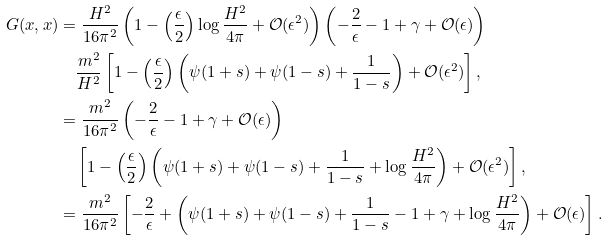Convert formula to latex. <formula><loc_0><loc_0><loc_500><loc_500>G ( x , x ) & = \frac { H ^ { 2 } } { 1 6 \pi ^ { 2 } } \left ( 1 - \left ( \frac { \epsilon } { 2 } \right ) \log \frac { H ^ { 2 } } { 4 \pi } + \mathcal { O } ( \epsilon ^ { 2 } ) \right ) \left ( - \frac { 2 } { \epsilon } - 1 + \gamma + \mathcal { O } ( \epsilon ) \right ) \\ & \quad \frac { m ^ { 2 } } { H ^ { 2 } } \left [ 1 - \left ( \frac { \epsilon } { 2 } \right ) \left ( \psi ( 1 + s ) + \psi ( 1 - s ) + \frac { 1 } { 1 - s } \right ) + \mathcal { O } ( \epsilon ^ { 2 } ) \right ] , \\ & = \frac { m ^ { 2 } } { 1 6 \pi ^ { 2 } } \left ( - \frac { 2 } { \epsilon } - 1 + \gamma + \mathcal { O } ( \epsilon ) \right ) \\ & \quad \left [ 1 - \left ( \frac { \epsilon } { 2 } \right ) \left ( \psi ( 1 + s ) + \psi ( 1 - s ) + \frac { 1 } { 1 - s } + \log \frac { H ^ { 2 } } { 4 \pi } \right ) + \mathcal { O } ( \epsilon ^ { 2 } ) \right ] , \\ & = \frac { m ^ { 2 } } { 1 6 \pi ^ { 2 } } \left [ - \frac { 2 } { \epsilon } + \left ( \psi ( 1 + s ) + \psi ( 1 - s ) + \frac { 1 } { 1 - s } - 1 + \gamma + \log \frac { H ^ { 2 } } { 4 \pi } \right ) + \mathcal { O } ( \epsilon ) \right ] .</formula> 